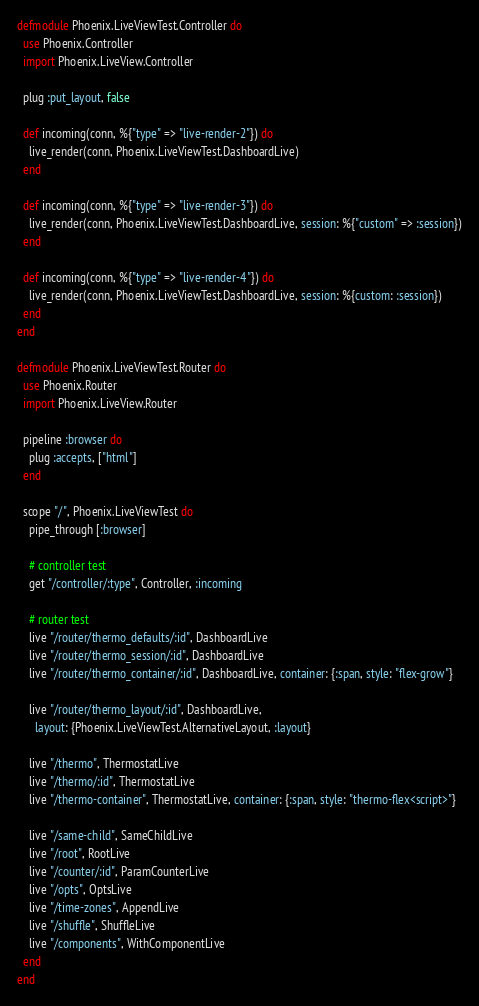Convert code to text. <code><loc_0><loc_0><loc_500><loc_500><_Elixir_>defmodule Phoenix.LiveViewTest.Controller do
  use Phoenix.Controller
  import Phoenix.LiveView.Controller

  plug :put_layout, false

  def incoming(conn, %{"type" => "live-render-2"}) do
    live_render(conn, Phoenix.LiveViewTest.DashboardLive)
  end

  def incoming(conn, %{"type" => "live-render-3"}) do
    live_render(conn, Phoenix.LiveViewTest.DashboardLive, session: %{"custom" => :session})
  end

  def incoming(conn, %{"type" => "live-render-4"}) do
    live_render(conn, Phoenix.LiveViewTest.DashboardLive, session: %{custom: :session})
  end
end

defmodule Phoenix.LiveViewTest.Router do
  use Phoenix.Router
  import Phoenix.LiveView.Router

  pipeline :browser do
    plug :accepts, ["html"]
  end

  scope "/", Phoenix.LiveViewTest do
    pipe_through [:browser]

    # controller test
    get "/controller/:type", Controller, :incoming

    # router test
    live "/router/thermo_defaults/:id", DashboardLive
    live "/router/thermo_session/:id", DashboardLive
    live "/router/thermo_container/:id", DashboardLive, container: {:span, style: "flex-grow"}

    live "/router/thermo_layout/:id", DashboardLive,
      layout: {Phoenix.LiveViewTest.AlternativeLayout, :layout}

    live "/thermo", ThermostatLive
    live "/thermo/:id", ThermostatLive
    live "/thermo-container", ThermostatLive, container: {:span, style: "thermo-flex<script>"}

    live "/same-child", SameChildLive
    live "/root", RootLive
    live "/counter/:id", ParamCounterLive
    live "/opts", OptsLive
    live "/time-zones", AppendLive
    live "/shuffle", ShuffleLive
    live "/components", WithComponentLive
  end
end
</code> 